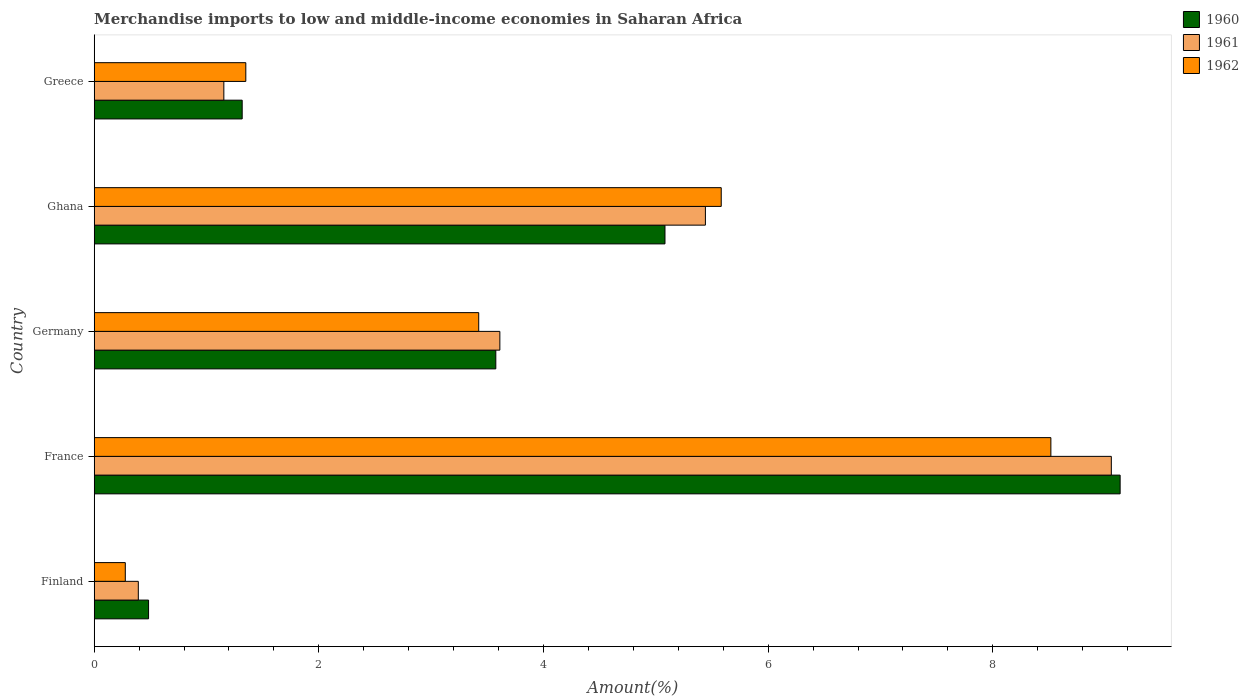Are the number of bars on each tick of the Y-axis equal?
Your answer should be very brief. Yes. What is the label of the 2nd group of bars from the top?
Offer a terse response. Ghana. What is the percentage of amount earned from merchandise imports in 1962 in Finland?
Offer a very short reply. 0.28. Across all countries, what is the maximum percentage of amount earned from merchandise imports in 1962?
Your response must be concise. 8.52. Across all countries, what is the minimum percentage of amount earned from merchandise imports in 1961?
Make the answer very short. 0.39. In which country was the percentage of amount earned from merchandise imports in 1961 minimum?
Provide a succinct answer. Finland. What is the total percentage of amount earned from merchandise imports in 1961 in the graph?
Make the answer very short. 19.65. What is the difference between the percentage of amount earned from merchandise imports in 1962 in France and that in Germany?
Offer a terse response. 5.09. What is the difference between the percentage of amount earned from merchandise imports in 1961 in Ghana and the percentage of amount earned from merchandise imports in 1960 in Germany?
Ensure brevity in your answer.  1.87. What is the average percentage of amount earned from merchandise imports in 1960 per country?
Provide a succinct answer. 3.92. What is the difference between the percentage of amount earned from merchandise imports in 1960 and percentage of amount earned from merchandise imports in 1962 in France?
Your answer should be very brief. 0.62. What is the ratio of the percentage of amount earned from merchandise imports in 1960 in Finland to that in France?
Your answer should be compact. 0.05. What is the difference between the highest and the second highest percentage of amount earned from merchandise imports in 1962?
Provide a succinct answer. 2.93. What is the difference between the highest and the lowest percentage of amount earned from merchandise imports in 1960?
Offer a terse response. 8.65. What does the 1st bar from the top in Germany represents?
Provide a short and direct response. 1962. What does the 1st bar from the bottom in Greece represents?
Your answer should be compact. 1960. Is it the case that in every country, the sum of the percentage of amount earned from merchandise imports in 1961 and percentage of amount earned from merchandise imports in 1962 is greater than the percentage of amount earned from merchandise imports in 1960?
Give a very brief answer. Yes. Are all the bars in the graph horizontal?
Your answer should be very brief. Yes. How many countries are there in the graph?
Provide a short and direct response. 5. What is the difference between two consecutive major ticks on the X-axis?
Your response must be concise. 2. Does the graph contain any zero values?
Keep it short and to the point. No. How many legend labels are there?
Provide a short and direct response. 3. What is the title of the graph?
Make the answer very short. Merchandise imports to low and middle-income economies in Saharan Africa. What is the label or title of the X-axis?
Offer a terse response. Amount(%). What is the label or title of the Y-axis?
Your response must be concise. Country. What is the Amount(%) of 1960 in Finland?
Offer a very short reply. 0.48. What is the Amount(%) of 1961 in Finland?
Provide a succinct answer. 0.39. What is the Amount(%) in 1962 in Finland?
Ensure brevity in your answer.  0.28. What is the Amount(%) in 1960 in France?
Give a very brief answer. 9.13. What is the Amount(%) of 1961 in France?
Ensure brevity in your answer.  9.06. What is the Amount(%) in 1962 in France?
Give a very brief answer. 8.52. What is the Amount(%) in 1960 in Germany?
Your answer should be very brief. 3.58. What is the Amount(%) of 1961 in Germany?
Offer a terse response. 3.61. What is the Amount(%) in 1962 in Germany?
Keep it short and to the point. 3.42. What is the Amount(%) of 1960 in Ghana?
Ensure brevity in your answer.  5.08. What is the Amount(%) in 1961 in Ghana?
Provide a succinct answer. 5.44. What is the Amount(%) of 1962 in Ghana?
Keep it short and to the point. 5.58. What is the Amount(%) in 1960 in Greece?
Ensure brevity in your answer.  1.32. What is the Amount(%) in 1961 in Greece?
Offer a very short reply. 1.15. What is the Amount(%) of 1962 in Greece?
Ensure brevity in your answer.  1.35. Across all countries, what is the maximum Amount(%) of 1960?
Make the answer very short. 9.13. Across all countries, what is the maximum Amount(%) in 1961?
Keep it short and to the point. 9.06. Across all countries, what is the maximum Amount(%) in 1962?
Give a very brief answer. 8.52. Across all countries, what is the minimum Amount(%) in 1960?
Your answer should be very brief. 0.48. Across all countries, what is the minimum Amount(%) of 1961?
Ensure brevity in your answer.  0.39. Across all countries, what is the minimum Amount(%) in 1962?
Ensure brevity in your answer.  0.28. What is the total Amount(%) of 1960 in the graph?
Your answer should be compact. 19.59. What is the total Amount(%) in 1961 in the graph?
Your answer should be very brief. 19.65. What is the total Amount(%) in 1962 in the graph?
Provide a succinct answer. 19.15. What is the difference between the Amount(%) of 1960 in Finland and that in France?
Offer a terse response. -8.65. What is the difference between the Amount(%) of 1961 in Finland and that in France?
Ensure brevity in your answer.  -8.66. What is the difference between the Amount(%) of 1962 in Finland and that in France?
Ensure brevity in your answer.  -8.24. What is the difference between the Amount(%) in 1960 in Finland and that in Germany?
Offer a terse response. -3.09. What is the difference between the Amount(%) in 1961 in Finland and that in Germany?
Make the answer very short. -3.22. What is the difference between the Amount(%) of 1962 in Finland and that in Germany?
Provide a short and direct response. -3.15. What is the difference between the Amount(%) in 1960 in Finland and that in Ghana?
Provide a short and direct response. -4.6. What is the difference between the Amount(%) of 1961 in Finland and that in Ghana?
Ensure brevity in your answer.  -5.05. What is the difference between the Amount(%) of 1962 in Finland and that in Ghana?
Ensure brevity in your answer.  -5.31. What is the difference between the Amount(%) of 1960 in Finland and that in Greece?
Provide a succinct answer. -0.83. What is the difference between the Amount(%) of 1961 in Finland and that in Greece?
Offer a terse response. -0.76. What is the difference between the Amount(%) of 1962 in Finland and that in Greece?
Ensure brevity in your answer.  -1.07. What is the difference between the Amount(%) of 1960 in France and that in Germany?
Offer a terse response. 5.56. What is the difference between the Amount(%) of 1961 in France and that in Germany?
Provide a succinct answer. 5.44. What is the difference between the Amount(%) of 1962 in France and that in Germany?
Make the answer very short. 5.09. What is the difference between the Amount(%) of 1960 in France and that in Ghana?
Offer a very short reply. 4.05. What is the difference between the Amount(%) in 1961 in France and that in Ghana?
Ensure brevity in your answer.  3.61. What is the difference between the Amount(%) in 1962 in France and that in Ghana?
Your response must be concise. 2.93. What is the difference between the Amount(%) of 1960 in France and that in Greece?
Offer a very short reply. 7.82. What is the difference between the Amount(%) of 1961 in France and that in Greece?
Offer a very short reply. 7.9. What is the difference between the Amount(%) of 1962 in France and that in Greece?
Provide a short and direct response. 7.17. What is the difference between the Amount(%) of 1960 in Germany and that in Ghana?
Provide a succinct answer. -1.51. What is the difference between the Amount(%) in 1961 in Germany and that in Ghana?
Provide a short and direct response. -1.83. What is the difference between the Amount(%) of 1962 in Germany and that in Ghana?
Keep it short and to the point. -2.16. What is the difference between the Amount(%) of 1960 in Germany and that in Greece?
Make the answer very short. 2.26. What is the difference between the Amount(%) of 1961 in Germany and that in Greece?
Your answer should be compact. 2.46. What is the difference between the Amount(%) in 1962 in Germany and that in Greece?
Your answer should be very brief. 2.07. What is the difference between the Amount(%) of 1960 in Ghana and that in Greece?
Offer a very short reply. 3.76. What is the difference between the Amount(%) of 1961 in Ghana and that in Greece?
Your answer should be very brief. 4.29. What is the difference between the Amount(%) of 1962 in Ghana and that in Greece?
Offer a terse response. 4.23. What is the difference between the Amount(%) of 1960 in Finland and the Amount(%) of 1961 in France?
Your answer should be compact. -8.57. What is the difference between the Amount(%) of 1960 in Finland and the Amount(%) of 1962 in France?
Give a very brief answer. -8.03. What is the difference between the Amount(%) in 1961 in Finland and the Amount(%) in 1962 in France?
Give a very brief answer. -8.12. What is the difference between the Amount(%) in 1960 in Finland and the Amount(%) in 1961 in Germany?
Keep it short and to the point. -3.13. What is the difference between the Amount(%) of 1960 in Finland and the Amount(%) of 1962 in Germany?
Your answer should be compact. -2.94. What is the difference between the Amount(%) in 1961 in Finland and the Amount(%) in 1962 in Germany?
Your response must be concise. -3.03. What is the difference between the Amount(%) in 1960 in Finland and the Amount(%) in 1961 in Ghana?
Make the answer very short. -4.96. What is the difference between the Amount(%) in 1960 in Finland and the Amount(%) in 1962 in Ghana?
Your response must be concise. -5.1. What is the difference between the Amount(%) of 1961 in Finland and the Amount(%) of 1962 in Ghana?
Keep it short and to the point. -5.19. What is the difference between the Amount(%) in 1960 in Finland and the Amount(%) in 1961 in Greece?
Your answer should be very brief. -0.67. What is the difference between the Amount(%) of 1960 in Finland and the Amount(%) of 1962 in Greece?
Make the answer very short. -0.87. What is the difference between the Amount(%) in 1961 in Finland and the Amount(%) in 1962 in Greece?
Ensure brevity in your answer.  -0.96. What is the difference between the Amount(%) in 1960 in France and the Amount(%) in 1961 in Germany?
Give a very brief answer. 5.52. What is the difference between the Amount(%) in 1960 in France and the Amount(%) in 1962 in Germany?
Provide a short and direct response. 5.71. What is the difference between the Amount(%) of 1961 in France and the Amount(%) of 1962 in Germany?
Your response must be concise. 5.63. What is the difference between the Amount(%) in 1960 in France and the Amount(%) in 1961 in Ghana?
Provide a short and direct response. 3.69. What is the difference between the Amount(%) in 1960 in France and the Amount(%) in 1962 in Ghana?
Your answer should be compact. 3.55. What is the difference between the Amount(%) of 1961 in France and the Amount(%) of 1962 in Ghana?
Offer a very short reply. 3.47. What is the difference between the Amount(%) of 1960 in France and the Amount(%) of 1961 in Greece?
Provide a succinct answer. 7.98. What is the difference between the Amount(%) in 1960 in France and the Amount(%) in 1962 in Greece?
Your response must be concise. 7.78. What is the difference between the Amount(%) in 1961 in France and the Amount(%) in 1962 in Greece?
Your response must be concise. 7.71. What is the difference between the Amount(%) of 1960 in Germany and the Amount(%) of 1961 in Ghana?
Offer a terse response. -1.87. What is the difference between the Amount(%) of 1960 in Germany and the Amount(%) of 1962 in Ghana?
Provide a succinct answer. -2.01. What is the difference between the Amount(%) in 1961 in Germany and the Amount(%) in 1962 in Ghana?
Your answer should be very brief. -1.97. What is the difference between the Amount(%) in 1960 in Germany and the Amount(%) in 1961 in Greece?
Offer a terse response. 2.42. What is the difference between the Amount(%) of 1960 in Germany and the Amount(%) of 1962 in Greece?
Your response must be concise. 2.23. What is the difference between the Amount(%) of 1961 in Germany and the Amount(%) of 1962 in Greece?
Your response must be concise. 2.26. What is the difference between the Amount(%) of 1960 in Ghana and the Amount(%) of 1961 in Greece?
Offer a terse response. 3.93. What is the difference between the Amount(%) in 1960 in Ghana and the Amount(%) in 1962 in Greece?
Your answer should be very brief. 3.73. What is the difference between the Amount(%) of 1961 in Ghana and the Amount(%) of 1962 in Greece?
Your answer should be very brief. 4.09. What is the average Amount(%) of 1960 per country?
Your answer should be very brief. 3.92. What is the average Amount(%) in 1961 per country?
Give a very brief answer. 3.93. What is the average Amount(%) of 1962 per country?
Your response must be concise. 3.83. What is the difference between the Amount(%) in 1960 and Amount(%) in 1961 in Finland?
Keep it short and to the point. 0.09. What is the difference between the Amount(%) in 1960 and Amount(%) in 1962 in Finland?
Make the answer very short. 0.21. What is the difference between the Amount(%) in 1961 and Amount(%) in 1962 in Finland?
Make the answer very short. 0.12. What is the difference between the Amount(%) in 1960 and Amount(%) in 1961 in France?
Provide a succinct answer. 0.08. What is the difference between the Amount(%) of 1960 and Amount(%) of 1962 in France?
Offer a terse response. 0.62. What is the difference between the Amount(%) in 1961 and Amount(%) in 1962 in France?
Your answer should be very brief. 0.54. What is the difference between the Amount(%) of 1960 and Amount(%) of 1961 in Germany?
Your response must be concise. -0.04. What is the difference between the Amount(%) in 1960 and Amount(%) in 1962 in Germany?
Offer a terse response. 0.15. What is the difference between the Amount(%) of 1961 and Amount(%) of 1962 in Germany?
Your answer should be compact. 0.19. What is the difference between the Amount(%) of 1960 and Amount(%) of 1961 in Ghana?
Your response must be concise. -0.36. What is the difference between the Amount(%) of 1960 and Amount(%) of 1962 in Ghana?
Provide a succinct answer. -0.5. What is the difference between the Amount(%) of 1961 and Amount(%) of 1962 in Ghana?
Make the answer very short. -0.14. What is the difference between the Amount(%) of 1960 and Amount(%) of 1961 in Greece?
Make the answer very short. 0.16. What is the difference between the Amount(%) in 1960 and Amount(%) in 1962 in Greece?
Provide a succinct answer. -0.03. What is the difference between the Amount(%) of 1961 and Amount(%) of 1962 in Greece?
Offer a very short reply. -0.2. What is the ratio of the Amount(%) of 1960 in Finland to that in France?
Offer a very short reply. 0.05. What is the ratio of the Amount(%) of 1961 in Finland to that in France?
Your answer should be compact. 0.04. What is the ratio of the Amount(%) of 1962 in Finland to that in France?
Provide a succinct answer. 0.03. What is the ratio of the Amount(%) in 1960 in Finland to that in Germany?
Make the answer very short. 0.14. What is the ratio of the Amount(%) of 1961 in Finland to that in Germany?
Offer a very short reply. 0.11. What is the ratio of the Amount(%) in 1962 in Finland to that in Germany?
Offer a very short reply. 0.08. What is the ratio of the Amount(%) in 1960 in Finland to that in Ghana?
Your response must be concise. 0.1. What is the ratio of the Amount(%) in 1961 in Finland to that in Ghana?
Offer a very short reply. 0.07. What is the ratio of the Amount(%) of 1962 in Finland to that in Ghana?
Your answer should be very brief. 0.05. What is the ratio of the Amount(%) in 1960 in Finland to that in Greece?
Give a very brief answer. 0.37. What is the ratio of the Amount(%) of 1961 in Finland to that in Greece?
Ensure brevity in your answer.  0.34. What is the ratio of the Amount(%) in 1962 in Finland to that in Greece?
Ensure brevity in your answer.  0.21. What is the ratio of the Amount(%) in 1960 in France to that in Germany?
Ensure brevity in your answer.  2.55. What is the ratio of the Amount(%) in 1961 in France to that in Germany?
Your answer should be compact. 2.51. What is the ratio of the Amount(%) of 1962 in France to that in Germany?
Your answer should be very brief. 2.49. What is the ratio of the Amount(%) in 1960 in France to that in Ghana?
Offer a terse response. 1.8. What is the ratio of the Amount(%) of 1961 in France to that in Ghana?
Ensure brevity in your answer.  1.66. What is the ratio of the Amount(%) of 1962 in France to that in Ghana?
Give a very brief answer. 1.53. What is the ratio of the Amount(%) in 1960 in France to that in Greece?
Offer a very short reply. 6.93. What is the ratio of the Amount(%) in 1961 in France to that in Greece?
Provide a short and direct response. 7.85. What is the ratio of the Amount(%) in 1962 in France to that in Greece?
Offer a very short reply. 6.31. What is the ratio of the Amount(%) of 1960 in Germany to that in Ghana?
Your answer should be very brief. 0.7. What is the ratio of the Amount(%) of 1961 in Germany to that in Ghana?
Give a very brief answer. 0.66. What is the ratio of the Amount(%) in 1962 in Germany to that in Ghana?
Your answer should be very brief. 0.61. What is the ratio of the Amount(%) in 1960 in Germany to that in Greece?
Make the answer very short. 2.71. What is the ratio of the Amount(%) of 1961 in Germany to that in Greece?
Give a very brief answer. 3.13. What is the ratio of the Amount(%) of 1962 in Germany to that in Greece?
Offer a terse response. 2.54. What is the ratio of the Amount(%) of 1960 in Ghana to that in Greece?
Give a very brief answer. 3.86. What is the ratio of the Amount(%) in 1961 in Ghana to that in Greece?
Give a very brief answer. 4.71. What is the ratio of the Amount(%) of 1962 in Ghana to that in Greece?
Provide a succinct answer. 4.14. What is the difference between the highest and the second highest Amount(%) in 1960?
Keep it short and to the point. 4.05. What is the difference between the highest and the second highest Amount(%) in 1961?
Your answer should be very brief. 3.61. What is the difference between the highest and the second highest Amount(%) in 1962?
Your answer should be very brief. 2.93. What is the difference between the highest and the lowest Amount(%) in 1960?
Give a very brief answer. 8.65. What is the difference between the highest and the lowest Amount(%) in 1961?
Ensure brevity in your answer.  8.66. What is the difference between the highest and the lowest Amount(%) of 1962?
Make the answer very short. 8.24. 